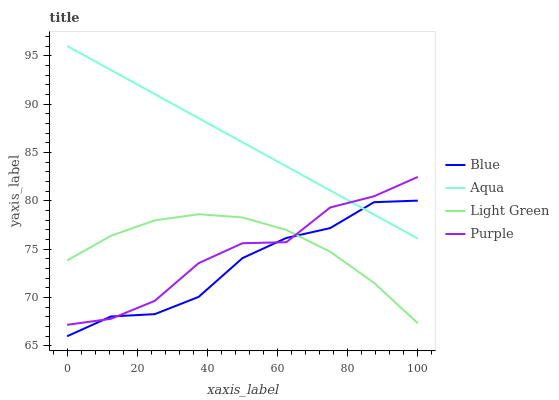Does Blue have the minimum area under the curve?
Answer yes or no. Yes. Does Aqua have the maximum area under the curve?
Answer yes or no. Yes. Does Purple have the minimum area under the curve?
Answer yes or no. No. Does Purple have the maximum area under the curve?
Answer yes or no. No. Is Aqua the smoothest?
Answer yes or no. Yes. Is Purple the roughest?
Answer yes or no. Yes. Is Purple the smoothest?
Answer yes or no. No. Is Aqua the roughest?
Answer yes or no. No. Does Blue have the lowest value?
Answer yes or no. Yes. Does Purple have the lowest value?
Answer yes or no. No. Does Aqua have the highest value?
Answer yes or no. Yes. Does Purple have the highest value?
Answer yes or no. No. Is Light Green less than Aqua?
Answer yes or no. Yes. Is Aqua greater than Light Green?
Answer yes or no. Yes. Does Aqua intersect Blue?
Answer yes or no. Yes. Is Aqua less than Blue?
Answer yes or no. No. Is Aqua greater than Blue?
Answer yes or no. No. Does Light Green intersect Aqua?
Answer yes or no. No. 